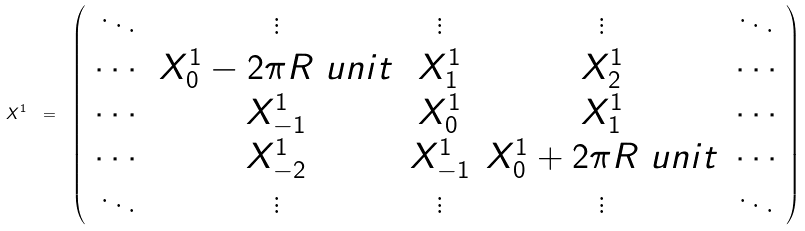Convert formula to latex. <formula><loc_0><loc_0><loc_500><loc_500>X ^ { 1 } \ = \ \left ( \begin{array} { c c c c c } \ddots & \vdots & \vdots & \vdots & \ddots \\ \cdots & X ^ { 1 } _ { 0 } - 2 \pi R \ u n i t & X ^ { 1 } _ { 1 } & X ^ { 1 } _ { 2 } & \cdots \\ \cdots & X ^ { 1 } _ { - 1 } & X ^ { 1 } _ { 0 } & X ^ { 1 } _ { 1 } & \cdots \\ \cdots & X ^ { 1 } _ { - 2 } & X ^ { 1 } _ { - 1 } & X ^ { 1 } _ { 0 } + 2 \pi R \ u n i t & \cdots \\ \ddots & \vdots & \vdots & \vdots & \ddots \\ \end{array} \right )</formula> 